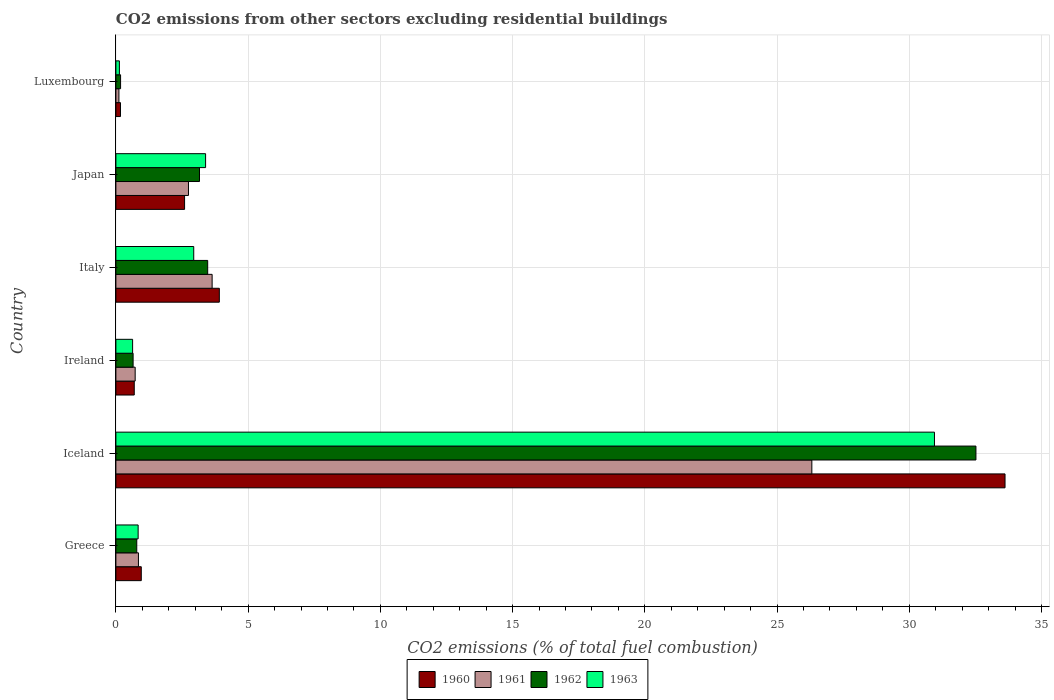How many different coloured bars are there?
Your answer should be very brief. 4. Are the number of bars per tick equal to the number of legend labels?
Your answer should be very brief. Yes. How many bars are there on the 5th tick from the top?
Offer a terse response. 4. What is the label of the 3rd group of bars from the top?
Keep it short and to the point. Italy. In how many cases, is the number of bars for a given country not equal to the number of legend labels?
Provide a succinct answer. 0. What is the total CO2 emitted in 1962 in Luxembourg?
Your answer should be very brief. 0.18. Across all countries, what is the maximum total CO2 emitted in 1960?
Provide a succinct answer. 33.62. Across all countries, what is the minimum total CO2 emitted in 1961?
Give a very brief answer. 0.11. In which country was the total CO2 emitted in 1961 maximum?
Make the answer very short. Iceland. In which country was the total CO2 emitted in 1960 minimum?
Your answer should be compact. Luxembourg. What is the total total CO2 emitted in 1961 in the graph?
Ensure brevity in your answer.  34.4. What is the difference between the total CO2 emitted in 1960 in Greece and that in Iceland?
Your answer should be very brief. -32.66. What is the difference between the total CO2 emitted in 1960 in Greece and the total CO2 emitted in 1963 in Luxembourg?
Make the answer very short. 0.83. What is the average total CO2 emitted in 1963 per country?
Make the answer very short. 6.48. What is the difference between the total CO2 emitted in 1962 and total CO2 emitted in 1960 in Luxembourg?
Offer a very short reply. 0. What is the ratio of the total CO2 emitted in 1962 in Greece to that in Italy?
Keep it short and to the point. 0.23. What is the difference between the highest and the second highest total CO2 emitted in 1962?
Keep it short and to the point. 29.05. What is the difference between the highest and the lowest total CO2 emitted in 1960?
Your answer should be very brief. 33.45. In how many countries, is the total CO2 emitted in 1962 greater than the average total CO2 emitted in 1962 taken over all countries?
Make the answer very short. 1. What does the 2nd bar from the top in Japan represents?
Offer a very short reply. 1962. Are all the bars in the graph horizontal?
Ensure brevity in your answer.  Yes. How many countries are there in the graph?
Keep it short and to the point. 6. Where does the legend appear in the graph?
Offer a terse response. Bottom center. What is the title of the graph?
Offer a very short reply. CO2 emissions from other sectors excluding residential buildings. Does "1990" appear as one of the legend labels in the graph?
Keep it short and to the point. No. What is the label or title of the X-axis?
Make the answer very short. CO2 emissions (% of total fuel combustion). What is the CO2 emissions (% of total fuel combustion) of 1960 in Greece?
Give a very brief answer. 0.96. What is the CO2 emissions (% of total fuel combustion) in 1961 in Greece?
Your answer should be very brief. 0.85. What is the CO2 emissions (% of total fuel combustion) of 1962 in Greece?
Keep it short and to the point. 0.79. What is the CO2 emissions (% of total fuel combustion) in 1963 in Greece?
Give a very brief answer. 0.84. What is the CO2 emissions (% of total fuel combustion) in 1960 in Iceland?
Your answer should be very brief. 33.62. What is the CO2 emissions (% of total fuel combustion) in 1961 in Iceland?
Your response must be concise. 26.32. What is the CO2 emissions (% of total fuel combustion) of 1962 in Iceland?
Provide a succinct answer. 32.52. What is the CO2 emissions (% of total fuel combustion) of 1963 in Iceland?
Ensure brevity in your answer.  30.95. What is the CO2 emissions (% of total fuel combustion) in 1960 in Ireland?
Your response must be concise. 0.69. What is the CO2 emissions (% of total fuel combustion) of 1961 in Ireland?
Make the answer very short. 0.73. What is the CO2 emissions (% of total fuel combustion) in 1962 in Ireland?
Your answer should be very brief. 0.65. What is the CO2 emissions (% of total fuel combustion) in 1963 in Ireland?
Offer a terse response. 0.63. What is the CO2 emissions (% of total fuel combustion) of 1960 in Italy?
Make the answer very short. 3.91. What is the CO2 emissions (% of total fuel combustion) of 1961 in Italy?
Make the answer very short. 3.64. What is the CO2 emissions (% of total fuel combustion) of 1962 in Italy?
Your answer should be compact. 3.47. What is the CO2 emissions (% of total fuel combustion) of 1963 in Italy?
Offer a terse response. 2.94. What is the CO2 emissions (% of total fuel combustion) in 1960 in Japan?
Give a very brief answer. 2.6. What is the CO2 emissions (% of total fuel combustion) in 1961 in Japan?
Your response must be concise. 2.74. What is the CO2 emissions (% of total fuel combustion) in 1962 in Japan?
Ensure brevity in your answer.  3.16. What is the CO2 emissions (% of total fuel combustion) of 1963 in Japan?
Offer a terse response. 3.39. What is the CO2 emissions (% of total fuel combustion) in 1960 in Luxembourg?
Keep it short and to the point. 0.17. What is the CO2 emissions (% of total fuel combustion) in 1961 in Luxembourg?
Offer a terse response. 0.11. What is the CO2 emissions (% of total fuel combustion) of 1962 in Luxembourg?
Give a very brief answer. 0.18. What is the CO2 emissions (% of total fuel combustion) in 1963 in Luxembourg?
Keep it short and to the point. 0.13. Across all countries, what is the maximum CO2 emissions (% of total fuel combustion) of 1960?
Your response must be concise. 33.62. Across all countries, what is the maximum CO2 emissions (% of total fuel combustion) in 1961?
Your answer should be very brief. 26.32. Across all countries, what is the maximum CO2 emissions (% of total fuel combustion) in 1962?
Keep it short and to the point. 32.52. Across all countries, what is the maximum CO2 emissions (% of total fuel combustion) of 1963?
Keep it short and to the point. 30.95. Across all countries, what is the minimum CO2 emissions (% of total fuel combustion) in 1960?
Provide a succinct answer. 0.17. Across all countries, what is the minimum CO2 emissions (% of total fuel combustion) in 1961?
Your answer should be compact. 0.11. Across all countries, what is the minimum CO2 emissions (% of total fuel combustion) of 1962?
Your answer should be very brief. 0.18. Across all countries, what is the minimum CO2 emissions (% of total fuel combustion) in 1963?
Offer a very short reply. 0.13. What is the total CO2 emissions (% of total fuel combustion) of 1960 in the graph?
Your answer should be very brief. 41.96. What is the total CO2 emissions (% of total fuel combustion) of 1961 in the graph?
Give a very brief answer. 34.4. What is the total CO2 emissions (% of total fuel combustion) of 1962 in the graph?
Ensure brevity in your answer.  40.77. What is the total CO2 emissions (% of total fuel combustion) of 1963 in the graph?
Provide a succinct answer. 38.89. What is the difference between the CO2 emissions (% of total fuel combustion) of 1960 in Greece and that in Iceland?
Ensure brevity in your answer.  -32.66. What is the difference between the CO2 emissions (% of total fuel combustion) in 1961 in Greece and that in Iceland?
Provide a short and direct response. -25.46. What is the difference between the CO2 emissions (% of total fuel combustion) of 1962 in Greece and that in Iceland?
Provide a succinct answer. -31.73. What is the difference between the CO2 emissions (% of total fuel combustion) in 1963 in Greece and that in Iceland?
Offer a very short reply. -30.11. What is the difference between the CO2 emissions (% of total fuel combustion) of 1960 in Greece and that in Ireland?
Ensure brevity in your answer.  0.27. What is the difference between the CO2 emissions (% of total fuel combustion) in 1961 in Greece and that in Ireland?
Provide a short and direct response. 0.12. What is the difference between the CO2 emissions (% of total fuel combustion) in 1962 in Greece and that in Ireland?
Offer a terse response. 0.14. What is the difference between the CO2 emissions (% of total fuel combustion) of 1963 in Greece and that in Ireland?
Ensure brevity in your answer.  0.21. What is the difference between the CO2 emissions (% of total fuel combustion) in 1960 in Greece and that in Italy?
Provide a short and direct response. -2.95. What is the difference between the CO2 emissions (% of total fuel combustion) in 1961 in Greece and that in Italy?
Provide a short and direct response. -2.79. What is the difference between the CO2 emissions (% of total fuel combustion) in 1962 in Greece and that in Italy?
Your response must be concise. -2.68. What is the difference between the CO2 emissions (% of total fuel combustion) of 1963 in Greece and that in Italy?
Ensure brevity in your answer.  -2.1. What is the difference between the CO2 emissions (% of total fuel combustion) of 1960 in Greece and that in Japan?
Keep it short and to the point. -1.64. What is the difference between the CO2 emissions (% of total fuel combustion) of 1961 in Greece and that in Japan?
Provide a succinct answer. -1.89. What is the difference between the CO2 emissions (% of total fuel combustion) of 1962 in Greece and that in Japan?
Provide a short and direct response. -2.37. What is the difference between the CO2 emissions (% of total fuel combustion) of 1963 in Greece and that in Japan?
Make the answer very short. -2.55. What is the difference between the CO2 emissions (% of total fuel combustion) of 1960 in Greece and that in Luxembourg?
Your answer should be very brief. 0.79. What is the difference between the CO2 emissions (% of total fuel combustion) in 1961 in Greece and that in Luxembourg?
Your response must be concise. 0.74. What is the difference between the CO2 emissions (% of total fuel combustion) in 1962 in Greece and that in Luxembourg?
Provide a succinct answer. 0.61. What is the difference between the CO2 emissions (% of total fuel combustion) of 1963 in Greece and that in Luxembourg?
Provide a succinct answer. 0.71. What is the difference between the CO2 emissions (% of total fuel combustion) of 1960 in Iceland and that in Ireland?
Your answer should be very brief. 32.93. What is the difference between the CO2 emissions (% of total fuel combustion) of 1961 in Iceland and that in Ireland?
Keep it short and to the point. 25.59. What is the difference between the CO2 emissions (% of total fuel combustion) of 1962 in Iceland and that in Ireland?
Ensure brevity in your answer.  31.87. What is the difference between the CO2 emissions (% of total fuel combustion) of 1963 in Iceland and that in Ireland?
Ensure brevity in your answer.  30.32. What is the difference between the CO2 emissions (% of total fuel combustion) of 1960 in Iceland and that in Italy?
Offer a very short reply. 29.71. What is the difference between the CO2 emissions (% of total fuel combustion) in 1961 in Iceland and that in Italy?
Give a very brief answer. 22.68. What is the difference between the CO2 emissions (% of total fuel combustion) of 1962 in Iceland and that in Italy?
Provide a succinct answer. 29.05. What is the difference between the CO2 emissions (% of total fuel combustion) in 1963 in Iceland and that in Italy?
Provide a succinct answer. 28.01. What is the difference between the CO2 emissions (% of total fuel combustion) in 1960 in Iceland and that in Japan?
Your answer should be compact. 31.02. What is the difference between the CO2 emissions (% of total fuel combustion) of 1961 in Iceland and that in Japan?
Provide a short and direct response. 23.57. What is the difference between the CO2 emissions (% of total fuel combustion) in 1962 in Iceland and that in Japan?
Ensure brevity in your answer.  29.36. What is the difference between the CO2 emissions (% of total fuel combustion) in 1963 in Iceland and that in Japan?
Provide a short and direct response. 27.56. What is the difference between the CO2 emissions (% of total fuel combustion) of 1960 in Iceland and that in Luxembourg?
Provide a short and direct response. 33.45. What is the difference between the CO2 emissions (% of total fuel combustion) in 1961 in Iceland and that in Luxembourg?
Make the answer very short. 26.2. What is the difference between the CO2 emissions (% of total fuel combustion) in 1962 in Iceland and that in Luxembourg?
Offer a terse response. 32.34. What is the difference between the CO2 emissions (% of total fuel combustion) in 1963 in Iceland and that in Luxembourg?
Provide a succinct answer. 30.82. What is the difference between the CO2 emissions (% of total fuel combustion) of 1960 in Ireland and that in Italy?
Offer a terse response. -3.22. What is the difference between the CO2 emissions (% of total fuel combustion) in 1961 in Ireland and that in Italy?
Provide a short and direct response. -2.91. What is the difference between the CO2 emissions (% of total fuel combustion) in 1962 in Ireland and that in Italy?
Make the answer very short. -2.82. What is the difference between the CO2 emissions (% of total fuel combustion) of 1963 in Ireland and that in Italy?
Offer a very short reply. -2.31. What is the difference between the CO2 emissions (% of total fuel combustion) in 1960 in Ireland and that in Japan?
Offer a very short reply. -1.9. What is the difference between the CO2 emissions (% of total fuel combustion) of 1961 in Ireland and that in Japan?
Your answer should be compact. -2.02. What is the difference between the CO2 emissions (% of total fuel combustion) in 1962 in Ireland and that in Japan?
Provide a short and direct response. -2.51. What is the difference between the CO2 emissions (% of total fuel combustion) of 1963 in Ireland and that in Japan?
Keep it short and to the point. -2.76. What is the difference between the CO2 emissions (% of total fuel combustion) in 1960 in Ireland and that in Luxembourg?
Provide a short and direct response. 0.52. What is the difference between the CO2 emissions (% of total fuel combustion) in 1961 in Ireland and that in Luxembourg?
Keep it short and to the point. 0.61. What is the difference between the CO2 emissions (% of total fuel combustion) in 1962 in Ireland and that in Luxembourg?
Your response must be concise. 0.47. What is the difference between the CO2 emissions (% of total fuel combustion) of 1963 in Ireland and that in Luxembourg?
Keep it short and to the point. 0.5. What is the difference between the CO2 emissions (% of total fuel combustion) of 1960 in Italy and that in Japan?
Your answer should be very brief. 1.31. What is the difference between the CO2 emissions (% of total fuel combustion) in 1961 in Italy and that in Japan?
Your answer should be very brief. 0.89. What is the difference between the CO2 emissions (% of total fuel combustion) of 1962 in Italy and that in Japan?
Give a very brief answer. 0.31. What is the difference between the CO2 emissions (% of total fuel combustion) in 1963 in Italy and that in Japan?
Offer a terse response. -0.45. What is the difference between the CO2 emissions (% of total fuel combustion) of 1960 in Italy and that in Luxembourg?
Your response must be concise. 3.74. What is the difference between the CO2 emissions (% of total fuel combustion) in 1961 in Italy and that in Luxembourg?
Keep it short and to the point. 3.52. What is the difference between the CO2 emissions (% of total fuel combustion) of 1962 in Italy and that in Luxembourg?
Your answer should be very brief. 3.29. What is the difference between the CO2 emissions (% of total fuel combustion) of 1963 in Italy and that in Luxembourg?
Give a very brief answer. 2.81. What is the difference between the CO2 emissions (% of total fuel combustion) of 1960 in Japan and that in Luxembourg?
Your answer should be very brief. 2.42. What is the difference between the CO2 emissions (% of total fuel combustion) in 1961 in Japan and that in Luxembourg?
Make the answer very short. 2.63. What is the difference between the CO2 emissions (% of total fuel combustion) of 1962 in Japan and that in Luxembourg?
Your response must be concise. 2.98. What is the difference between the CO2 emissions (% of total fuel combustion) in 1963 in Japan and that in Luxembourg?
Keep it short and to the point. 3.26. What is the difference between the CO2 emissions (% of total fuel combustion) in 1960 in Greece and the CO2 emissions (% of total fuel combustion) in 1961 in Iceland?
Offer a very short reply. -25.36. What is the difference between the CO2 emissions (% of total fuel combustion) in 1960 in Greece and the CO2 emissions (% of total fuel combustion) in 1962 in Iceland?
Your answer should be compact. -31.56. What is the difference between the CO2 emissions (% of total fuel combustion) in 1960 in Greece and the CO2 emissions (% of total fuel combustion) in 1963 in Iceland?
Ensure brevity in your answer.  -29.99. What is the difference between the CO2 emissions (% of total fuel combustion) in 1961 in Greece and the CO2 emissions (% of total fuel combustion) in 1962 in Iceland?
Your response must be concise. -31.67. What is the difference between the CO2 emissions (% of total fuel combustion) in 1961 in Greece and the CO2 emissions (% of total fuel combustion) in 1963 in Iceland?
Provide a short and direct response. -30.1. What is the difference between the CO2 emissions (% of total fuel combustion) in 1962 in Greece and the CO2 emissions (% of total fuel combustion) in 1963 in Iceland?
Make the answer very short. -30.16. What is the difference between the CO2 emissions (% of total fuel combustion) in 1960 in Greece and the CO2 emissions (% of total fuel combustion) in 1961 in Ireland?
Offer a terse response. 0.23. What is the difference between the CO2 emissions (% of total fuel combustion) of 1960 in Greece and the CO2 emissions (% of total fuel combustion) of 1962 in Ireland?
Keep it short and to the point. 0.31. What is the difference between the CO2 emissions (% of total fuel combustion) of 1960 in Greece and the CO2 emissions (% of total fuel combustion) of 1963 in Ireland?
Offer a very short reply. 0.33. What is the difference between the CO2 emissions (% of total fuel combustion) of 1961 in Greece and the CO2 emissions (% of total fuel combustion) of 1962 in Ireland?
Your response must be concise. 0.2. What is the difference between the CO2 emissions (% of total fuel combustion) of 1961 in Greece and the CO2 emissions (% of total fuel combustion) of 1963 in Ireland?
Offer a very short reply. 0.22. What is the difference between the CO2 emissions (% of total fuel combustion) in 1962 in Greece and the CO2 emissions (% of total fuel combustion) in 1963 in Ireland?
Your answer should be very brief. 0.16. What is the difference between the CO2 emissions (% of total fuel combustion) of 1960 in Greece and the CO2 emissions (% of total fuel combustion) of 1961 in Italy?
Offer a very short reply. -2.68. What is the difference between the CO2 emissions (% of total fuel combustion) in 1960 in Greece and the CO2 emissions (% of total fuel combustion) in 1962 in Italy?
Keep it short and to the point. -2.51. What is the difference between the CO2 emissions (% of total fuel combustion) in 1960 in Greece and the CO2 emissions (% of total fuel combustion) in 1963 in Italy?
Keep it short and to the point. -1.98. What is the difference between the CO2 emissions (% of total fuel combustion) in 1961 in Greece and the CO2 emissions (% of total fuel combustion) in 1962 in Italy?
Provide a succinct answer. -2.62. What is the difference between the CO2 emissions (% of total fuel combustion) of 1961 in Greece and the CO2 emissions (% of total fuel combustion) of 1963 in Italy?
Ensure brevity in your answer.  -2.09. What is the difference between the CO2 emissions (% of total fuel combustion) of 1962 in Greece and the CO2 emissions (% of total fuel combustion) of 1963 in Italy?
Ensure brevity in your answer.  -2.15. What is the difference between the CO2 emissions (% of total fuel combustion) of 1960 in Greece and the CO2 emissions (% of total fuel combustion) of 1961 in Japan?
Your answer should be very brief. -1.78. What is the difference between the CO2 emissions (% of total fuel combustion) in 1960 in Greece and the CO2 emissions (% of total fuel combustion) in 1962 in Japan?
Give a very brief answer. -2.2. What is the difference between the CO2 emissions (% of total fuel combustion) in 1960 in Greece and the CO2 emissions (% of total fuel combustion) in 1963 in Japan?
Make the answer very short. -2.43. What is the difference between the CO2 emissions (% of total fuel combustion) of 1961 in Greece and the CO2 emissions (% of total fuel combustion) of 1962 in Japan?
Ensure brevity in your answer.  -2.31. What is the difference between the CO2 emissions (% of total fuel combustion) in 1961 in Greece and the CO2 emissions (% of total fuel combustion) in 1963 in Japan?
Keep it short and to the point. -2.54. What is the difference between the CO2 emissions (% of total fuel combustion) of 1962 in Greece and the CO2 emissions (% of total fuel combustion) of 1963 in Japan?
Offer a very short reply. -2.6. What is the difference between the CO2 emissions (% of total fuel combustion) of 1960 in Greece and the CO2 emissions (% of total fuel combustion) of 1961 in Luxembourg?
Provide a short and direct response. 0.85. What is the difference between the CO2 emissions (% of total fuel combustion) in 1960 in Greece and the CO2 emissions (% of total fuel combustion) in 1962 in Luxembourg?
Offer a very short reply. 0.78. What is the difference between the CO2 emissions (% of total fuel combustion) in 1960 in Greece and the CO2 emissions (% of total fuel combustion) in 1963 in Luxembourg?
Offer a terse response. 0.83. What is the difference between the CO2 emissions (% of total fuel combustion) in 1961 in Greece and the CO2 emissions (% of total fuel combustion) in 1962 in Luxembourg?
Ensure brevity in your answer.  0.68. What is the difference between the CO2 emissions (% of total fuel combustion) of 1961 in Greece and the CO2 emissions (% of total fuel combustion) of 1963 in Luxembourg?
Provide a short and direct response. 0.72. What is the difference between the CO2 emissions (% of total fuel combustion) of 1962 in Greece and the CO2 emissions (% of total fuel combustion) of 1963 in Luxembourg?
Provide a succinct answer. 0.66. What is the difference between the CO2 emissions (% of total fuel combustion) of 1960 in Iceland and the CO2 emissions (% of total fuel combustion) of 1961 in Ireland?
Give a very brief answer. 32.89. What is the difference between the CO2 emissions (% of total fuel combustion) of 1960 in Iceland and the CO2 emissions (% of total fuel combustion) of 1962 in Ireland?
Make the answer very short. 32.97. What is the difference between the CO2 emissions (% of total fuel combustion) in 1960 in Iceland and the CO2 emissions (% of total fuel combustion) in 1963 in Ireland?
Keep it short and to the point. 32.99. What is the difference between the CO2 emissions (% of total fuel combustion) of 1961 in Iceland and the CO2 emissions (% of total fuel combustion) of 1962 in Ireland?
Ensure brevity in your answer.  25.66. What is the difference between the CO2 emissions (% of total fuel combustion) of 1961 in Iceland and the CO2 emissions (% of total fuel combustion) of 1963 in Ireland?
Ensure brevity in your answer.  25.68. What is the difference between the CO2 emissions (% of total fuel combustion) of 1962 in Iceland and the CO2 emissions (% of total fuel combustion) of 1963 in Ireland?
Ensure brevity in your answer.  31.89. What is the difference between the CO2 emissions (% of total fuel combustion) of 1960 in Iceland and the CO2 emissions (% of total fuel combustion) of 1961 in Italy?
Ensure brevity in your answer.  29.98. What is the difference between the CO2 emissions (% of total fuel combustion) of 1960 in Iceland and the CO2 emissions (% of total fuel combustion) of 1962 in Italy?
Ensure brevity in your answer.  30.15. What is the difference between the CO2 emissions (% of total fuel combustion) of 1960 in Iceland and the CO2 emissions (% of total fuel combustion) of 1963 in Italy?
Your response must be concise. 30.68. What is the difference between the CO2 emissions (% of total fuel combustion) of 1961 in Iceland and the CO2 emissions (% of total fuel combustion) of 1962 in Italy?
Provide a succinct answer. 22.84. What is the difference between the CO2 emissions (% of total fuel combustion) of 1961 in Iceland and the CO2 emissions (% of total fuel combustion) of 1963 in Italy?
Make the answer very short. 23.37. What is the difference between the CO2 emissions (% of total fuel combustion) of 1962 in Iceland and the CO2 emissions (% of total fuel combustion) of 1963 in Italy?
Provide a short and direct response. 29.58. What is the difference between the CO2 emissions (% of total fuel combustion) of 1960 in Iceland and the CO2 emissions (% of total fuel combustion) of 1961 in Japan?
Offer a terse response. 30.88. What is the difference between the CO2 emissions (% of total fuel combustion) in 1960 in Iceland and the CO2 emissions (% of total fuel combustion) in 1962 in Japan?
Provide a short and direct response. 30.46. What is the difference between the CO2 emissions (% of total fuel combustion) in 1960 in Iceland and the CO2 emissions (% of total fuel combustion) in 1963 in Japan?
Make the answer very short. 30.23. What is the difference between the CO2 emissions (% of total fuel combustion) in 1961 in Iceland and the CO2 emissions (% of total fuel combustion) in 1962 in Japan?
Provide a short and direct response. 23.15. What is the difference between the CO2 emissions (% of total fuel combustion) in 1961 in Iceland and the CO2 emissions (% of total fuel combustion) in 1963 in Japan?
Keep it short and to the point. 22.92. What is the difference between the CO2 emissions (% of total fuel combustion) in 1962 in Iceland and the CO2 emissions (% of total fuel combustion) in 1963 in Japan?
Provide a short and direct response. 29.13. What is the difference between the CO2 emissions (% of total fuel combustion) of 1960 in Iceland and the CO2 emissions (% of total fuel combustion) of 1961 in Luxembourg?
Ensure brevity in your answer.  33.51. What is the difference between the CO2 emissions (% of total fuel combustion) of 1960 in Iceland and the CO2 emissions (% of total fuel combustion) of 1962 in Luxembourg?
Ensure brevity in your answer.  33.44. What is the difference between the CO2 emissions (% of total fuel combustion) of 1960 in Iceland and the CO2 emissions (% of total fuel combustion) of 1963 in Luxembourg?
Your answer should be very brief. 33.49. What is the difference between the CO2 emissions (% of total fuel combustion) of 1961 in Iceland and the CO2 emissions (% of total fuel combustion) of 1962 in Luxembourg?
Your answer should be very brief. 26.14. What is the difference between the CO2 emissions (% of total fuel combustion) in 1961 in Iceland and the CO2 emissions (% of total fuel combustion) in 1963 in Luxembourg?
Ensure brevity in your answer.  26.18. What is the difference between the CO2 emissions (% of total fuel combustion) in 1962 in Iceland and the CO2 emissions (% of total fuel combustion) in 1963 in Luxembourg?
Your answer should be compact. 32.39. What is the difference between the CO2 emissions (% of total fuel combustion) in 1960 in Ireland and the CO2 emissions (% of total fuel combustion) in 1961 in Italy?
Your answer should be very brief. -2.94. What is the difference between the CO2 emissions (% of total fuel combustion) in 1960 in Ireland and the CO2 emissions (% of total fuel combustion) in 1962 in Italy?
Ensure brevity in your answer.  -2.78. What is the difference between the CO2 emissions (% of total fuel combustion) of 1960 in Ireland and the CO2 emissions (% of total fuel combustion) of 1963 in Italy?
Provide a short and direct response. -2.25. What is the difference between the CO2 emissions (% of total fuel combustion) of 1961 in Ireland and the CO2 emissions (% of total fuel combustion) of 1962 in Italy?
Provide a short and direct response. -2.74. What is the difference between the CO2 emissions (% of total fuel combustion) in 1961 in Ireland and the CO2 emissions (% of total fuel combustion) in 1963 in Italy?
Ensure brevity in your answer.  -2.21. What is the difference between the CO2 emissions (% of total fuel combustion) in 1962 in Ireland and the CO2 emissions (% of total fuel combustion) in 1963 in Italy?
Keep it short and to the point. -2.29. What is the difference between the CO2 emissions (% of total fuel combustion) of 1960 in Ireland and the CO2 emissions (% of total fuel combustion) of 1961 in Japan?
Provide a short and direct response. -2.05. What is the difference between the CO2 emissions (% of total fuel combustion) of 1960 in Ireland and the CO2 emissions (% of total fuel combustion) of 1962 in Japan?
Provide a short and direct response. -2.47. What is the difference between the CO2 emissions (% of total fuel combustion) of 1960 in Ireland and the CO2 emissions (% of total fuel combustion) of 1963 in Japan?
Offer a terse response. -2.7. What is the difference between the CO2 emissions (% of total fuel combustion) of 1961 in Ireland and the CO2 emissions (% of total fuel combustion) of 1962 in Japan?
Your response must be concise. -2.43. What is the difference between the CO2 emissions (% of total fuel combustion) of 1961 in Ireland and the CO2 emissions (% of total fuel combustion) of 1963 in Japan?
Ensure brevity in your answer.  -2.66. What is the difference between the CO2 emissions (% of total fuel combustion) in 1962 in Ireland and the CO2 emissions (% of total fuel combustion) in 1963 in Japan?
Your answer should be compact. -2.74. What is the difference between the CO2 emissions (% of total fuel combustion) of 1960 in Ireland and the CO2 emissions (% of total fuel combustion) of 1961 in Luxembourg?
Your answer should be very brief. 0.58. What is the difference between the CO2 emissions (% of total fuel combustion) in 1960 in Ireland and the CO2 emissions (% of total fuel combustion) in 1962 in Luxembourg?
Offer a very short reply. 0.52. What is the difference between the CO2 emissions (% of total fuel combustion) of 1960 in Ireland and the CO2 emissions (% of total fuel combustion) of 1963 in Luxembourg?
Offer a very short reply. 0.56. What is the difference between the CO2 emissions (% of total fuel combustion) of 1961 in Ireland and the CO2 emissions (% of total fuel combustion) of 1962 in Luxembourg?
Your response must be concise. 0.55. What is the difference between the CO2 emissions (% of total fuel combustion) in 1961 in Ireland and the CO2 emissions (% of total fuel combustion) in 1963 in Luxembourg?
Make the answer very short. 0.6. What is the difference between the CO2 emissions (% of total fuel combustion) of 1962 in Ireland and the CO2 emissions (% of total fuel combustion) of 1963 in Luxembourg?
Offer a very short reply. 0.52. What is the difference between the CO2 emissions (% of total fuel combustion) in 1960 in Italy and the CO2 emissions (% of total fuel combustion) in 1961 in Japan?
Provide a succinct answer. 1.17. What is the difference between the CO2 emissions (% of total fuel combustion) in 1960 in Italy and the CO2 emissions (% of total fuel combustion) in 1962 in Japan?
Provide a succinct answer. 0.75. What is the difference between the CO2 emissions (% of total fuel combustion) in 1960 in Italy and the CO2 emissions (% of total fuel combustion) in 1963 in Japan?
Offer a very short reply. 0.52. What is the difference between the CO2 emissions (% of total fuel combustion) of 1961 in Italy and the CO2 emissions (% of total fuel combustion) of 1962 in Japan?
Provide a short and direct response. 0.48. What is the difference between the CO2 emissions (% of total fuel combustion) in 1961 in Italy and the CO2 emissions (% of total fuel combustion) in 1963 in Japan?
Ensure brevity in your answer.  0.25. What is the difference between the CO2 emissions (% of total fuel combustion) in 1962 in Italy and the CO2 emissions (% of total fuel combustion) in 1963 in Japan?
Keep it short and to the point. 0.08. What is the difference between the CO2 emissions (% of total fuel combustion) of 1960 in Italy and the CO2 emissions (% of total fuel combustion) of 1961 in Luxembourg?
Offer a terse response. 3.8. What is the difference between the CO2 emissions (% of total fuel combustion) of 1960 in Italy and the CO2 emissions (% of total fuel combustion) of 1962 in Luxembourg?
Provide a succinct answer. 3.73. What is the difference between the CO2 emissions (% of total fuel combustion) in 1960 in Italy and the CO2 emissions (% of total fuel combustion) in 1963 in Luxembourg?
Provide a succinct answer. 3.78. What is the difference between the CO2 emissions (% of total fuel combustion) of 1961 in Italy and the CO2 emissions (% of total fuel combustion) of 1962 in Luxembourg?
Give a very brief answer. 3.46. What is the difference between the CO2 emissions (% of total fuel combustion) in 1961 in Italy and the CO2 emissions (% of total fuel combustion) in 1963 in Luxembourg?
Your answer should be very brief. 3.51. What is the difference between the CO2 emissions (% of total fuel combustion) of 1962 in Italy and the CO2 emissions (% of total fuel combustion) of 1963 in Luxembourg?
Ensure brevity in your answer.  3.34. What is the difference between the CO2 emissions (% of total fuel combustion) in 1960 in Japan and the CO2 emissions (% of total fuel combustion) in 1961 in Luxembourg?
Give a very brief answer. 2.48. What is the difference between the CO2 emissions (% of total fuel combustion) of 1960 in Japan and the CO2 emissions (% of total fuel combustion) of 1962 in Luxembourg?
Offer a terse response. 2.42. What is the difference between the CO2 emissions (% of total fuel combustion) in 1960 in Japan and the CO2 emissions (% of total fuel combustion) in 1963 in Luxembourg?
Your response must be concise. 2.46. What is the difference between the CO2 emissions (% of total fuel combustion) in 1961 in Japan and the CO2 emissions (% of total fuel combustion) in 1962 in Luxembourg?
Keep it short and to the point. 2.57. What is the difference between the CO2 emissions (% of total fuel combustion) in 1961 in Japan and the CO2 emissions (% of total fuel combustion) in 1963 in Luxembourg?
Your response must be concise. 2.61. What is the difference between the CO2 emissions (% of total fuel combustion) of 1962 in Japan and the CO2 emissions (% of total fuel combustion) of 1963 in Luxembourg?
Your response must be concise. 3.03. What is the average CO2 emissions (% of total fuel combustion) in 1960 per country?
Offer a terse response. 6.99. What is the average CO2 emissions (% of total fuel combustion) of 1961 per country?
Offer a very short reply. 5.73. What is the average CO2 emissions (% of total fuel combustion) of 1962 per country?
Your answer should be compact. 6.8. What is the average CO2 emissions (% of total fuel combustion) of 1963 per country?
Offer a terse response. 6.48. What is the difference between the CO2 emissions (% of total fuel combustion) of 1960 and CO2 emissions (% of total fuel combustion) of 1961 in Greece?
Your answer should be very brief. 0.11. What is the difference between the CO2 emissions (% of total fuel combustion) in 1960 and CO2 emissions (% of total fuel combustion) in 1962 in Greece?
Offer a terse response. 0.17. What is the difference between the CO2 emissions (% of total fuel combustion) of 1960 and CO2 emissions (% of total fuel combustion) of 1963 in Greece?
Make the answer very short. 0.12. What is the difference between the CO2 emissions (% of total fuel combustion) in 1961 and CO2 emissions (% of total fuel combustion) in 1962 in Greece?
Your answer should be very brief. 0.06. What is the difference between the CO2 emissions (% of total fuel combustion) in 1961 and CO2 emissions (% of total fuel combustion) in 1963 in Greece?
Provide a short and direct response. 0.01. What is the difference between the CO2 emissions (% of total fuel combustion) in 1962 and CO2 emissions (% of total fuel combustion) in 1963 in Greece?
Offer a very short reply. -0.05. What is the difference between the CO2 emissions (% of total fuel combustion) in 1960 and CO2 emissions (% of total fuel combustion) in 1961 in Iceland?
Provide a succinct answer. 7.3. What is the difference between the CO2 emissions (% of total fuel combustion) in 1960 and CO2 emissions (% of total fuel combustion) in 1962 in Iceland?
Make the answer very short. 1.1. What is the difference between the CO2 emissions (% of total fuel combustion) in 1960 and CO2 emissions (% of total fuel combustion) in 1963 in Iceland?
Ensure brevity in your answer.  2.67. What is the difference between the CO2 emissions (% of total fuel combustion) of 1961 and CO2 emissions (% of total fuel combustion) of 1962 in Iceland?
Your answer should be very brief. -6.2. What is the difference between the CO2 emissions (% of total fuel combustion) of 1961 and CO2 emissions (% of total fuel combustion) of 1963 in Iceland?
Your response must be concise. -4.64. What is the difference between the CO2 emissions (% of total fuel combustion) of 1962 and CO2 emissions (% of total fuel combustion) of 1963 in Iceland?
Ensure brevity in your answer.  1.57. What is the difference between the CO2 emissions (% of total fuel combustion) of 1960 and CO2 emissions (% of total fuel combustion) of 1961 in Ireland?
Ensure brevity in your answer.  -0.03. What is the difference between the CO2 emissions (% of total fuel combustion) of 1960 and CO2 emissions (% of total fuel combustion) of 1962 in Ireland?
Provide a succinct answer. 0.04. What is the difference between the CO2 emissions (% of total fuel combustion) of 1960 and CO2 emissions (% of total fuel combustion) of 1963 in Ireland?
Offer a very short reply. 0.06. What is the difference between the CO2 emissions (% of total fuel combustion) of 1961 and CO2 emissions (% of total fuel combustion) of 1962 in Ireland?
Offer a very short reply. 0.08. What is the difference between the CO2 emissions (% of total fuel combustion) of 1961 and CO2 emissions (% of total fuel combustion) of 1963 in Ireland?
Your answer should be very brief. 0.1. What is the difference between the CO2 emissions (% of total fuel combustion) in 1962 and CO2 emissions (% of total fuel combustion) in 1963 in Ireland?
Your response must be concise. 0.02. What is the difference between the CO2 emissions (% of total fuel combustion) in 1960 and CO2 emissions (% of total fuel combustion) in 1961 in Italy?
Offer a terse response. 0.27. What is the difference between the CO2 emissions (% of total fuel combustion) of 1960 and CO2 emissions (% of total fuel combustion) of 1962 in Italy?
Your response must be concise. 0.44. What is the difference between the CO2 emissions (% of total fuel combustion) in 1961 and CO2 emissions (% of total fuel combustion) in 1962 in Italy?
Offer a terse response. 0.17. What is the difference between the CO2 emissions (% of total fuel combustion) of 1961 and CO2 emissions (% of total fuel combustion) of 1963 in Italy?
Provide a short and direct response. 0.7. What is the difference between the CO2 emissions (% of total fuel combustion) in 1962 and CO2 emissions (% of total fuel combustion) in 1963 in Italy?
Provide a succinct answer. 0.53. What is the difference between the CO2 emissions (% of total fuel combustion) of 1960 and CO2 emissions (% of total fuel combustion) of 1961 in Japan?
Offer a terse response. -0.15. What is the difference between the CO2 emissions (% of total fuel combustion) in 1960 and CO2 emissions (% of total fuel combustion) in 1962 in Japan?
Make the answer very short. -0.56. What is the difference between the CO2 emissions (% of total fuel combustion) in 1960 and CO2 emissions (% of total fuel combustion) in 1963 in Japan?
Provide a succinct answer. -0.79. What is the difference between the CO2 emissions (% of total fuel combustion) of 1961 and CO2 emissions (% of total fuel combustion) of 1962 in Japan?
Your response must be concise. -0.42. What is the difference between the CO2 emissions (% of total fuel combustion) of 1961 and CO2 emissions (% of total fuel combustion) of 1963 in Japan?
Your answer should be compact. -0.65. What is the difference between the CO2 emissions (% of total fuel combustion) of 1962 and CO2 emissions (% of total fuel combustion) of 1963 in Japan?
Provide a succinct answer. -0.23. What is the difference between the CO2 emissions (% of total fuel combustion) of 1960 and CO2 emissions (% of total fuel combustion) of 1961 in Luxembourg?
Your answer should be very brief. 0.06. What is the difference between the CO2 emissions (% of total fuel combustion) of 1960 and CO2 emissions (% of total fuel combustion) of 1962 in Luxembourg?
Ensure brevity in your answer.  -0. What is the difference between the CO2 emissions (% of total fuel combustion) of 1960 and CO2 emissions (% of total fuel combustion) of 1963 in Luxembourg?
Your answer should be compact. 0.04. What is the difference between the CO2 emissions (% of total fuel combustion) in 1961 and CO2 emissions (% of total fuel combustion) in 1962 in Luxembourg?
Give a very brief answer. -0.06. What is the difference between the CO2 emissions (% of total fuel combustion) of 1961 and CO2 emissions (% of total fuel combustion) of 1963 in Luxembourg?
Give a very brief answer. -0.02. What is the difference between the CO2 emissions (% of total fuel combustion) of 1962 and CO2 emissions (% of total fuel combustion) of 1963 in Luxembourg?
Your answer should be compact. 0.04. What is the ratio of the CO2 emissions (% of total fuel combustion) in 1960 in Greece to that in Iceland?
Give a very brief answer. 0.03. What is the ratio of the CO2 emissions (% of total fuel combustion) of 1961 in Greece to that in Iceland?
Offer a very short reply. 0.03. What is the ratio of the CO2 emissions (% of total fuel combustion) of 1962 in Greece to that in Iceland?
Make the answer very short. 0.02. What is the ratio of the CO2 emissions (% of total fuel combustion) of 1963 in Greece to that in Iceland?
Your answer should be compact. 0.03. What is the ratio of the CO2 emissions (% of total fuel combustion) of 1960 in Greece to that in Ireland?
Your response must be concise. 1.38. What is the ratio of the CO2 emissions (% of total fuel combustion) in 1961 in Greece to that in Ireland?
Provide a succinct answer. 1.17. What is the ratio of the CO2 emissions (% of total fuel combustion) of 1962 in Greece to that in Ireland?
Provide a succinct answer. 1.21. What is the ratio of the CO2 emissions (% of total fuel combustion) of 1963 in Greece to that in Ireland?
Provide a short and direct response. 1.33. What is the ratio of the CO2 emissions (% of total fuel combustion) of 1960 in Greece to that in Italy?
Your response must be concise. 0.25. What is the ratio of the CO2 emissions (% of total fuel combustion) in 1961 in Greece to that in Italy?
Your answer should be very brief. 0.23. What is the ratio of the CO2 emissions (% of total fuel combustion) of 1962 in Greece to that in Italy?
Your answer should be compact. 0.23. What is the ratio of the CO2 emissions (% of total fuel combustion) in 1963 in Greece to that in Italy?
Ensure brevity in your answer.  0.29. What is the ratio of the CO2 emissions (% of total fuel combustion) in 1960 in Greece to that in Japan?
Offer a very short reply. 0.37. What is the ratio of the CO2 emissions (% of total fuel combustion) in 1961 in Greece to that in Japan?
Offer a terse response. 0.31. What is the ratio of the CO2 emissions (% of total fuel combustion) of 1962 in Greece to that in Japan?
Your response must be concise. 0.25. What is the ratio of the CO2 emissions (% of total fuel combustion) in 1963 in Greece to that in Japan?
Provide a short and direct response. 0.25. What is the ratio of the CO2 emissions (% of total fuel combustion) of 1960 in Greece to that in Luxembourg?
Provide a short and direct response. 5.52. What is the ratio of the CO2 emissions (% of total fuel combustion) of 1961 in Greece to that in Luxembourg?
Offer a very short reply. 7.44. What is the ratio of the CO2 emissions (% of total fuel combustion) of 1962 in Greece to that in Luxembourg?
Offer a terse response. 4.46. What is the ratio of the CO2 emissions (% of total fuel combustion) of 1963 in Greece to that in Luxembourg?
Keep it short and to the point. 6.34. What is the ratio of the CO2 emissions (% of total fuel combustion) of 1960 in Iceland to that in Ireland?
Give a very brief answer. 48.41. What is the ratio of the CO2 emissions (% of total fuel combustion) of 1961 in Iceland to that in Ireland?
Provide a succinct answer. 36.11. What is the ratio of the CO2 emissions (% of total fuel combustion) of 1962 in Iceland to that in Ireland?
Keep it short and to the point. 49.94. What is the ratio of the CO2 emissions (% of total fuel combustion) in 1963 in Iceland to that in Ireland?
Ensure brevity in your answer.  48.97. What is the ratio of the CO2 emissions (% of total fuel combustion) in 1960 in Iceland to that in Italy?
Give a very brief answer. 8.6. What is the ratio of the CO2 emissions (% of total fuel combustion) of 1961 in Iceland to that in Italy?
Provide a succinct answer. 7.23. What is the ratio of the CO2 emissions (% of total fuel combustion) in 1962 in Iceland to that in Italy?
Provide a succinct answer. 9.37. What is the ratio of the CO2 emissions (% of total fuel combustion) of 1963 in Iceland to that in Italy?
Make the answer very short. 10.52. What is the ratio of the CO2 emissions (% of total fuel combustion) in 1960 in Iceland to that in Japan?
Provide a succinct answer. 12.94. What is the ratio of the CO2 emissions (% of total fuel combustion) of 1961 in Iceland to that in Japan?
Provide a short and direct response. 9.59. What is the ratio of the CO2 emissions (% of total fuel combustion) in 1962 in Iceland to that in Japan?
Keep it short and to the point. 10.29. What is the ratio of the CO2 emissions (% of total fuel combustion) of 1963 in Iceland to that in Japan?
Keep it short and to the point. 9.13. What is the ratio of the CO2 emissions (% of total fuel combustion) in 1960 in Iceland to that in Luxembourg?
Your response must be concise. 193.21. What is the ratio of the CO2 emissions (% of total fuel combustion) of 1961 in Iceland to that in Luxembourg?
Offer a terse response. 229.61. What is the ratio of the CO2 emissions (% of total fuel combustion) in 1962 in Iceland to that in Luxembourg?
Keep it short and to the point. 183.63. What is the ratio of the CO2 emissions (% of total fuel combustion) in 1963 in Iceland to that in Luxembourg?
Your answer should be compact. 233.38. What is the ratio of the CO2 emissions (% of total fuel combustion) of 1960 in Ireland to that in Italy?
Keep it short and to the point. 0.18. What is the ratio of the CO2 emissions (% of total fuel combustion) of 1961 in Ireland to that in Italy?
Keep it short and to the point. 0.2. What is the ratio of the CO2 emissions (% of total fuel combustion) in 1962 in Ireland to that in Italy?
Give a very brief answer. 0.19. What is the ratio of the CO2 emissions (% of total fuel combustion) in 1963 in Ireland to that in Italy?
Ensure brevity in your answer.  0.21. What is the ratio of the CO2 emissions (% of total fuel combustion) of 1960 in Ireland to that in Japan?
Your response must be concise. 0.27. What is the ratio of the CO2 emissions (% of total fuel combustion) of 1961 in Ireland to that in Japan?
Provide a short and direct response. 0.27. What is the ratio of the CO2 emissions (% of total fuel combustion) of 1962 in Ireland to that in Japan?
Give a very brief answer. 0.21. What is the ratio of the CO2 emissions (% of total fuel combustion) of 1963 in Ireland to that in Japan?
Provide a short and direct response. 0.19. What is the ratio of the CO2 emissions (% of total fuel combustion) in 1960 in Ireland to that in Luxembourg?
Make the answer very short. 3.99. What is the ratio of the CO2 emissions (% of total fuel combustion) in 1961 in Ireland to that in Luxembourg?
Provide a succinct answer. 6.36. What is the ratio of the CO2 emissions (% of total fuel combustion) in 1962 in Ireland to that in Luxembourg?
Provide a short and direct response. 3.68. What is the ratio of the CO2 emissions (% of total fuel combustion) in 1963 in Ireland to that in Luxembourg?
Provide a short and direct response. 4.77. What is the ratio of the CO2 emissions (% of total fuel combustion) of 1960 in Italy to that in Japan?
Provide a succinct answer. 1.51. What is the ratio of the CO2 emissions (% of total fuel combustion) of 1961 in Italy to that in Japan?
Your answer should be very brief. 1.33. What is the ratio of the CO2 emissions (% of total fuel combustion) in 1962 in Italy to that in Japan?
Your answer should be compact. 1.1. What is the ratio of the CO2 emissions (% of total fuel combustion) in 1963 in Italy to that in Japan?
Your response must be concise. 0.87. What is the ratio of the CO2 emissions (% of total fuel combustion) of 1960 in Italy to that in Luxembourg?
Your answer should be compact. 22.48. What is the ratio of the CO2 emissions (% of total fuel combustion) in 1961 in Italy to that in Luxembourg?
Give a very brief answer. 31.75. What is the ratio of the CO2 emissions (% of total fuel combustion) in 1962 in Italy to that in Luxembourg?
Provide a succinct answer. 19.6. What is the ratio of the CO2 emissions (% of total fuel combustion) in 1963 in Italy to that in Luxembourg?
Make the answer very short. 22.19. What is the ratio of the CO2 emissions (% of total fuel combustion) in 1960 in Japan to that in Luxembourg?
Keep it short and to the point. 14.93. What is the ratio of the CO2 emissions (% of total fuel combustion) in 1961 in Japan to that in Luxembourg?
Offer a very short reply. 23.95. What is the ratio of the CO2 emissions (% of total fuel combustion) of 1962 in Japan to that in Luxembourg?
Ensure brevity in your answer.  17.85. What is the ratio of the CO2 emissions (% of total fuel combustion) of 1963 in Japan to that in Luxembourg?
Your answer should be very brief. 25.57. What is the difference between the highest and the second highest CO2 emissions (% of total fuel combustion) of 1960?
Provide a short and direct response. 29.71. What is the difference between the highest and the second highest CO2 emissions (% of total fuel combustion) of 1961?
Keep it short and to the point. 22.68. What is the difference between the highest and the second highest CO2 emissions (% of total fuel combustion) in 1962?
Offer a terse response. 29.05. What is the difference between the highest and the second highest CO2 emissions (% of total fuel combustion) in 1963?
Your answer should be compact. 27.56. What is the difference between the highest and the lowest CO2 emissions (% of total fuel combustion) of 1960?
Offer a very short reply. 33.45. What is the difference between the highest and the lowest CO2 emissions (% of total fuel combustion) in 1961?
Ensure brevity in your answer.  26.2. What is the difference between the highest and the lowest CO2 emissions (% of total fuel combustion) of 1962?
Offer a very short reply. 32.34. What is the difference between the highest and the lowest CO2 emissions (% of total fuel combustion) in 1963?
Offer a terse response. 30.82. 